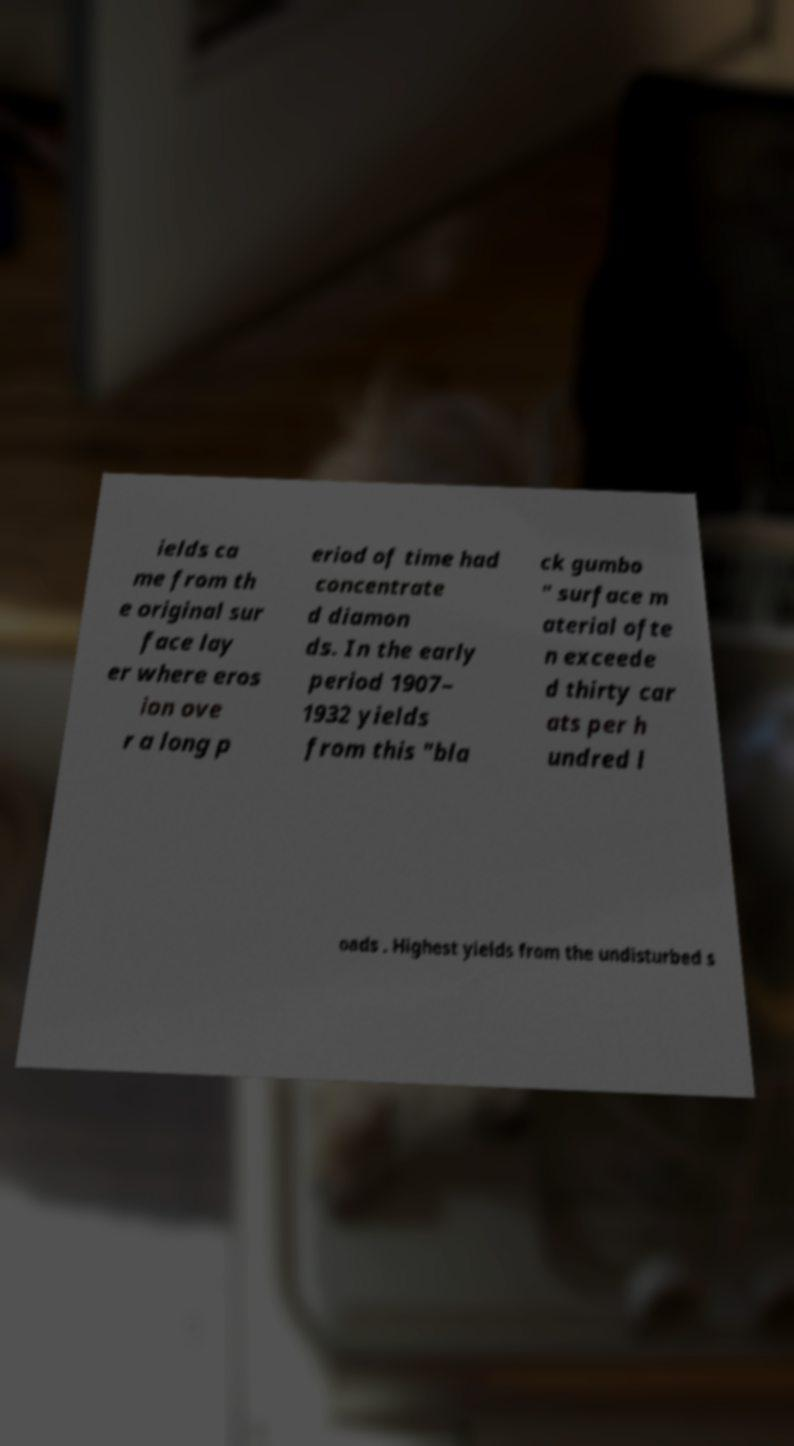What messages or text are displayed in this image? I need them in a readable, typed format. ields ca me from th e original sur face lay er where eros ion ove r a long p eriod of time had concentrate d diamon ds. In the early period 1907– 1932 yields from this "bla ck gumbo " surface m aterial ofte n exceede d thirty car ats per h undred l oads . Highest yields from the undisturbed s 